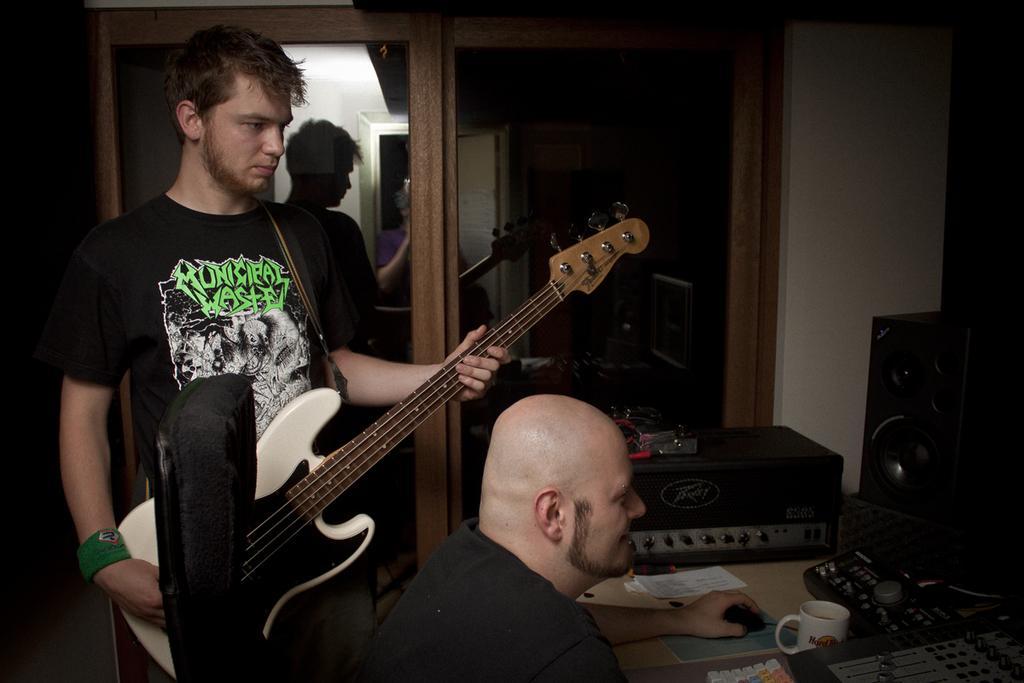Could you give a brief overview of what you see in this image? In this picture there are two people one among them is standing and holding a guitar and the other is sitting on the chair and playing some musical instrument. 